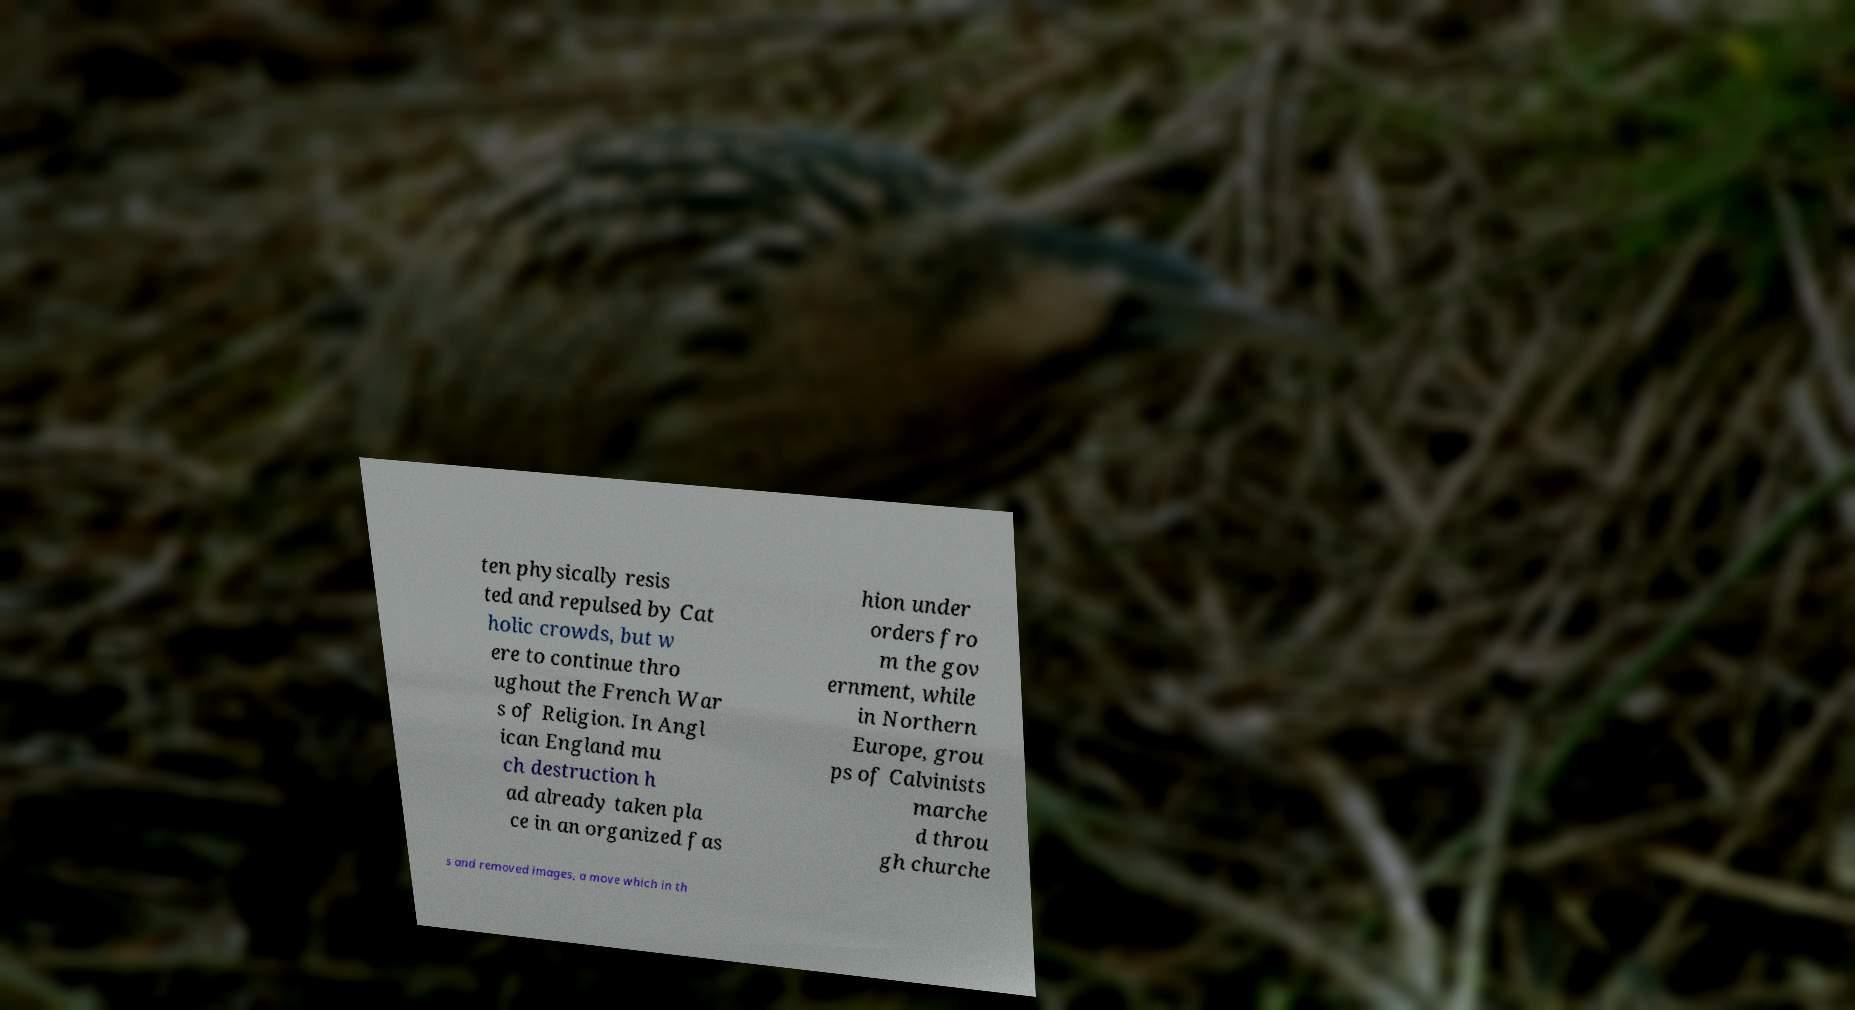I need the written content from this picture converted into text. Can you do that? ten physically resis ted and repulsed by Cat holic crowds, but w ere to continue thro ughout the French War s of Religion. In Angl ican England mu ch destruction h ad already taken pla ce in an organized fas hion under orders fro m the gov ernment, while in Northern Europe, grou ps of Calvinists marche d throu gh churche s and removed images, a move which in th 